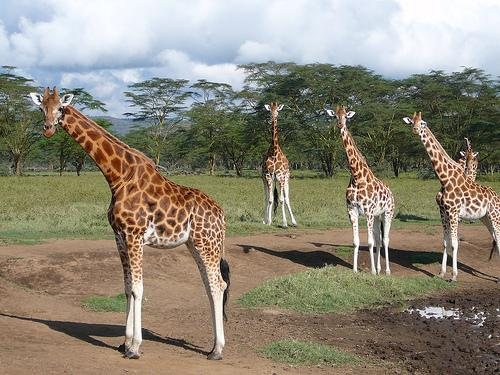What can be observed on the ground near the giraffes? Grass, mud, dirt patches, and a shadow can be observed on the ground near the giraffes. What can be seen in the background and the surroundings of the giraffes? Trees, white clouds in the blue sky, green grass, mud, and dirt patches can be seen as the surroundings of the giraffes. State the quantity and color of the clouds visible in the image. There are several white clouds in a blue sky. What is the general sentiment of the image? The sentiment of the image is calm and peaceful. Write a brief description of the overall image. The image consists of a group of tan and brown giraffes with brown spots standing in a field with trees, green grass, and cloudy blue sky in the background. How many total giraffes are captured in the image? There are four giraffes captured in the image. Identify the main object of interest in the image and list their different colors. The main object of interest is the giraffe, and it is tan and brown with brown spots. Analyze the interaction between the giraffes and their environment. The giraffes are standing in the dirt and interacting with their surroundings, such as the grass, mud, and trees, creating a harmonious and natural scene. Can you spot the baby giraffe hidden behind the trees? No, there is no baby giraffe hidden behind the trees in the image. Can you find the family of elephants playing near the mud? There are no elephants in the image. The instruction is misleading because it asks the viewer to look for a non-existent object (elephants). 